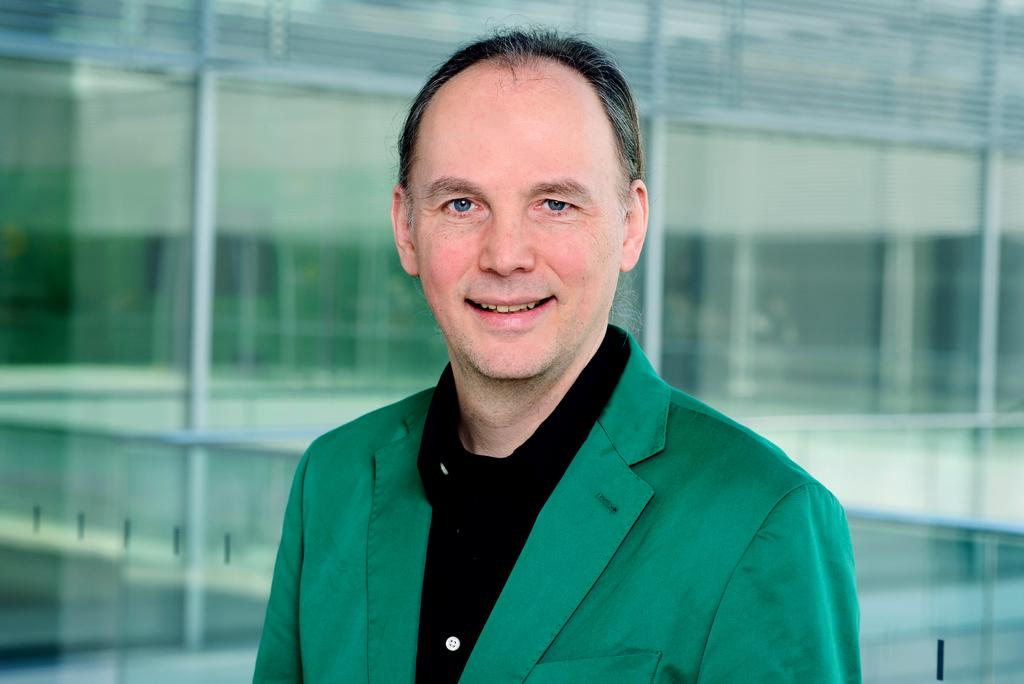Who is present in the image? There is a man in the image. What is the man wearing? The man is wearing a green suit. What can be seen in the background of the image? There is a glass and a building in the background of the image. How many ants can be seen crawling on the man's glove in the image? There are no ants or gloves present in the image. 